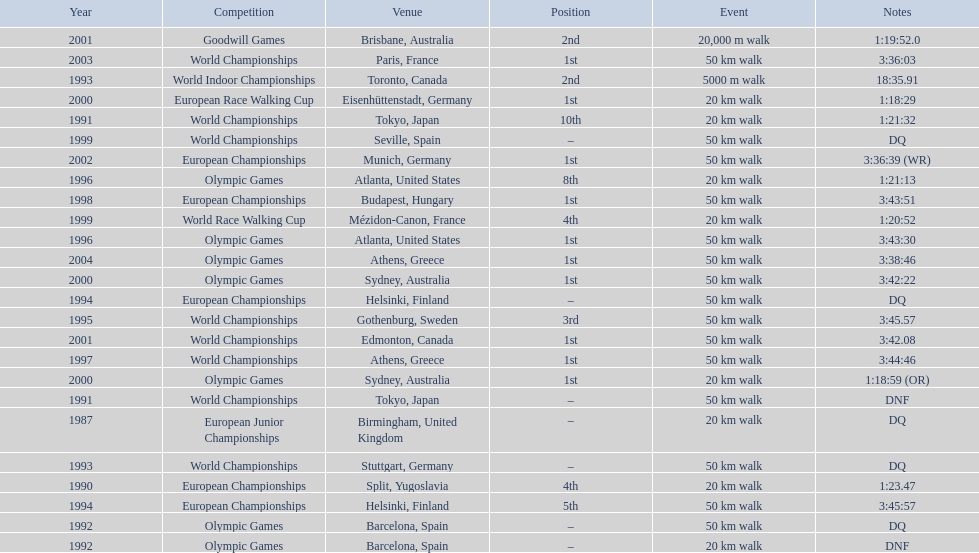Which of the competitions were 50 km walks? World Championships, Olympic Games, World Championships, European Championships, European Championships, World Championships, Olympic Games, World Championships, European Championships, World Championships, Olympic Games, World Championships, European Championships, World Championships, Olympic Games. Of these, which took place during or after the year 2000? Olympic Games, World Championships, European Championships, World Championships, Olympic Games. From these, which took place in athens, greece? Olympic Games. What was the time to finish for this competition? 3:38:46. 